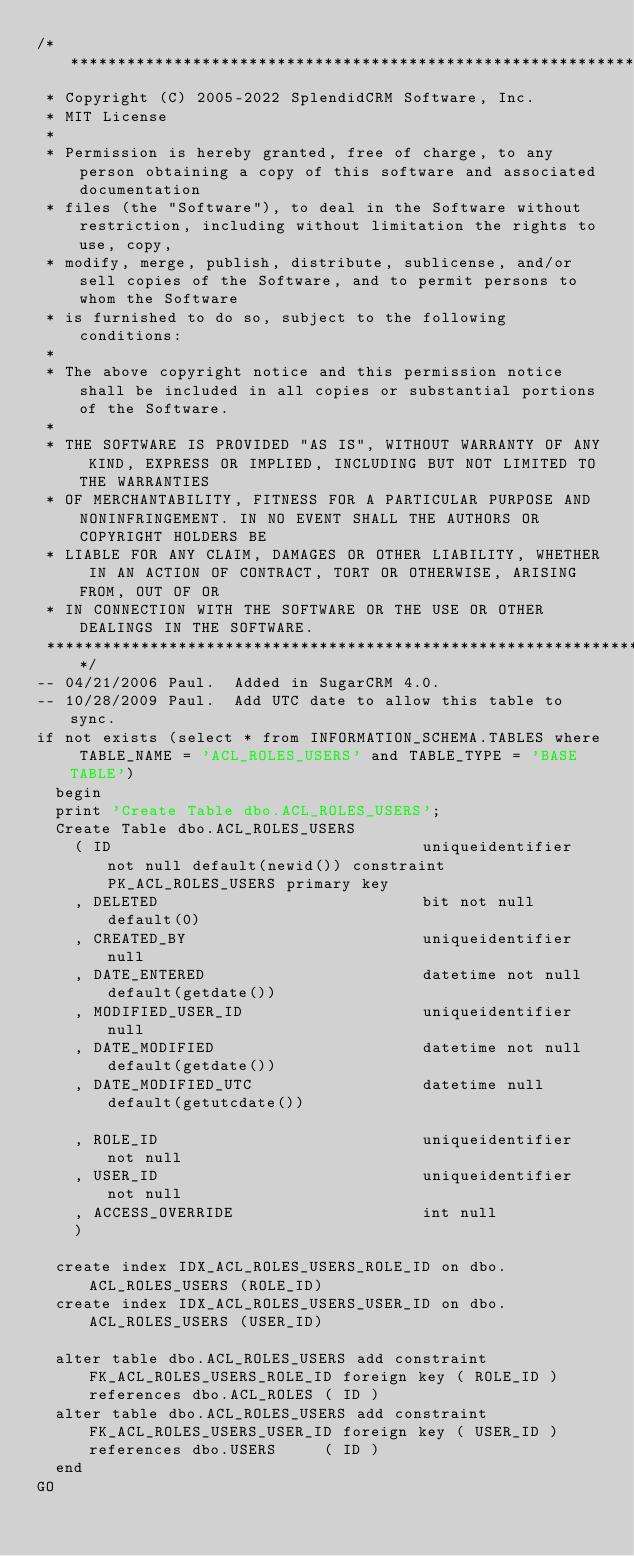<code> <loc_0><loc_0><loc_500><loc_500><_SQL_>/**********************************************************************************************************************
 * Copyright (C) 2005-2022 SplendidCRM Software, Inc. 
 * MIT License
 * 
 * Permission is hereby granted, free of charge, to any person obtaining a copy of this software and associated documentation 
 * files (the "Software"), to deal in the Software without restriction, including without limitation the rights to use, copy, 
 * modify, merge, publish, distribute, sublicense, and/or sell copies of the Software, and to permit persons to whom the Software 
 * is furnished to do so, subject to the following conditions:
 * 
 * The above copyright notice and this permission notice shall be included in all copies or substantial portions of the Software.
 * 
 * THE SOFTWARE IS PROVIDED "AS IS", WITHOUT WARRANTY OF ANY KIND, EXPRESS OR IMPLIED, INCLUDING BUT NOT LIMITED TO THE WARRANTIES 
 * OF MERCHANTABILITY, FITNESS FOR A PARTICULAR PURPOSE AND NONINFRINGEMENT. IN NO EVENT SHALL THE AUTHORS OR COPYRIGHT HOLDERS BE 
 * LIABLE FOR ANY CLAIM, DAMAGES OR OTHER LIABILITY, WHETHER IN AN ACTION OF CONTRACT, TORT OR OTHERWISE, ARISING FROM, OUT OF OR 
 * IN CONNECTION WITH THE SOFTWARE OR THE USE OR OTHER DEALINGS IN THE SOFTWARE.
 *********************************************************************************************************************/
-- 04/21/2006 Paul.  Added in SugarCRM 4.0.
-- 10/28/2009 Paul.  Add UTC date to allow this table to sync. 
if not exists (select * from INFORMATION_SCHEMA.TABLES where TABLE_NAME = 'ACL_ROLES_USERS' and TABLE_TYPE = 'BASE TABLE')
  begin
	print 'Create Table dbo.ACL_ROLES_USERS';
	Create Table dbo.ACL_ROLES_USERS
		( ID                                 uniqueidentifier not null default(newid()) constraint PK_ACL_ROLES_USERS primary key
		, DELETED                            bit not null default(0)
		, CREATED_BY                         uniqueidentifier null
		, DATE_ENTERED                       datetime not null default(getdate())
		, MODIFIED_USER_ID                   uniqueidentifier null
		, DATE_MODIFIED                      datetime not null default(getdate())
		, DATE_MODIFIED_UTC                  datetime null default(getutcdate())

		, ROLE_ID                            uniqueidentifier not null
		, USER_ID                            uniqueidentifier not null
		, ACCESS_OVERRIDE                    int null
		)

	create index IDX_ACL_ROLES_USERS_ROLE_ID on dbo.ACL_ROLES_USERS (ROLE_ID)
	create index IDX_ACL_ROLES_USERS_USER_ID on dbo.ACL_ROLES_USERS (USER_ID)

	alter table dbo.ACL_ROLES_USERS add constraint FK_ACL_ROLES_USERS_ROLE_ID foreign key ( ROLE_ID ) references dbo.ACL_ROLES ( ID )
	alter table dbo.ACL_ROLES_USERS add constraint FK_ACL_ROLES_USERS_USER_ID foreign key ( USER_ID ) references dbo.USERS     ( ID )
  end
GO


</code> 